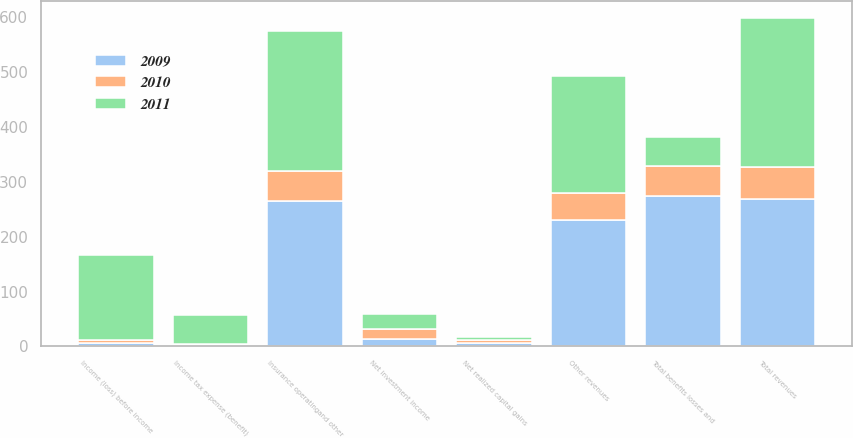<chart> <loc_0><loc_0><loc_500><loc_500><stacked_bar_chart><ecel><fcel>Net investment income<fcel>Net realized capital gains<fcel>Other revenues<fcel>Total revenues<fcel>Insurance operatingand other<fcel>Total benefits losses and<fcel>Income (loss) before income<fcel>Income tax expense (benefit)<nl><fcel>2010<fcel>17<fcel>6<fcel>48<fcel>59<fcel>54<fcel>54<fcel>5<fcel>1<nl><fcel>2011<fcel>28<fcel>5<fcel>213<fcel>272<fcel>256<fcel>53<fcel>154<fcel>53<nl><fcel>2009<fcel>14<fcel>6<fcel>231<fcel>268<fcel>265<fcel>275<fcel>7<fcel>3<nl></chart> 